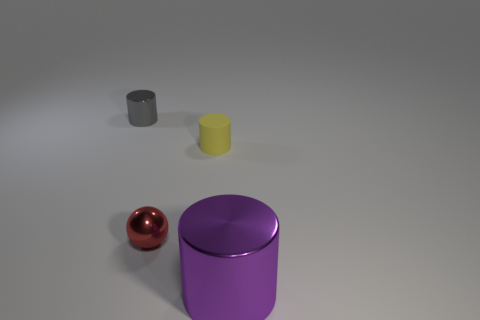Add 2 big blue rubber things. How many objects exist? 6 Subtract all cylinders. How many objects are left? 1 Subtract all tiny things. Subtract all big purple metallic things. How many objects are left? 0 Add 4 large purple metal objects. How many large purple metal objects are left? 5 Add 2 matte things. How many matte things exist? 3 Subtract 0 red cylinders. How many objects are left? 4 